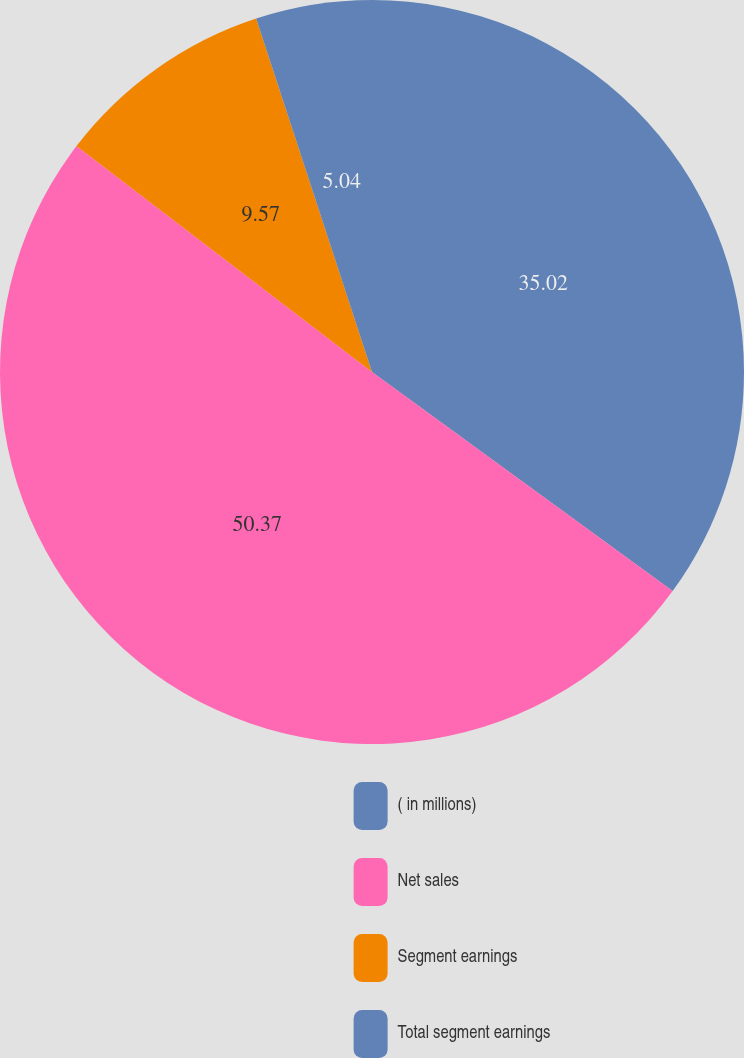<chart> <loc_0><loc_0><loc_500><loc_500><pie_chart><fcel>( in millions)<fcel>Net sales<fcel>Segment earnings<fcel>Total segment earnings<nl><fcel>35.02%<fcel>50.36%<fcel>9.57%<fcel>5.04%<nl></chart> 